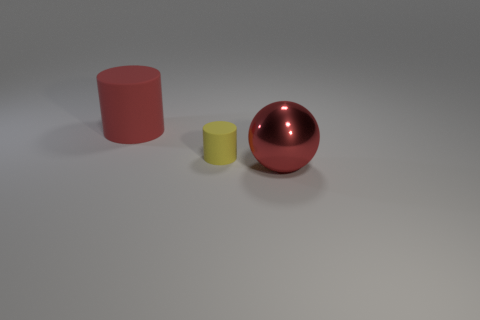What material is the thing that is the same color as the large cylinder?
Offer a very short reply. Metal. What is the color of the other matte thing that is the same shape as the big matte thing?
Provide a succinct answer. Yellow. What is the shape of the big red thing to the right of the cylinder on the right side of the big red object behind the big red metal object?
Keep it short and to the point. Sphere. Is the large metal object the same shape as the small yellow matte object?
Offer a very short reply. No. There is a red thing that is left of the matte thing in front of the big rubber cylinder; what shape is it?
Offer a terse response. Cylinder. Are any small yellow blocks visible?
Make the answer very short. No. What number of large cylinders are right of the big red rubber thing that is on the left side of the big red object in front of the yellow rubber thing?
Keep it short and to the point. 0. There is a yellow rubber thing; is it the same shape as the large red object left of the big shiny object?
Your answer should be compact. Yes. Is the number of large red metallic spheres greater than the number of big green blocks?
Your response must be concise. Yes. Is there any other thing that has the same size as the red ball?
Provide a short and direct response. Yes. 